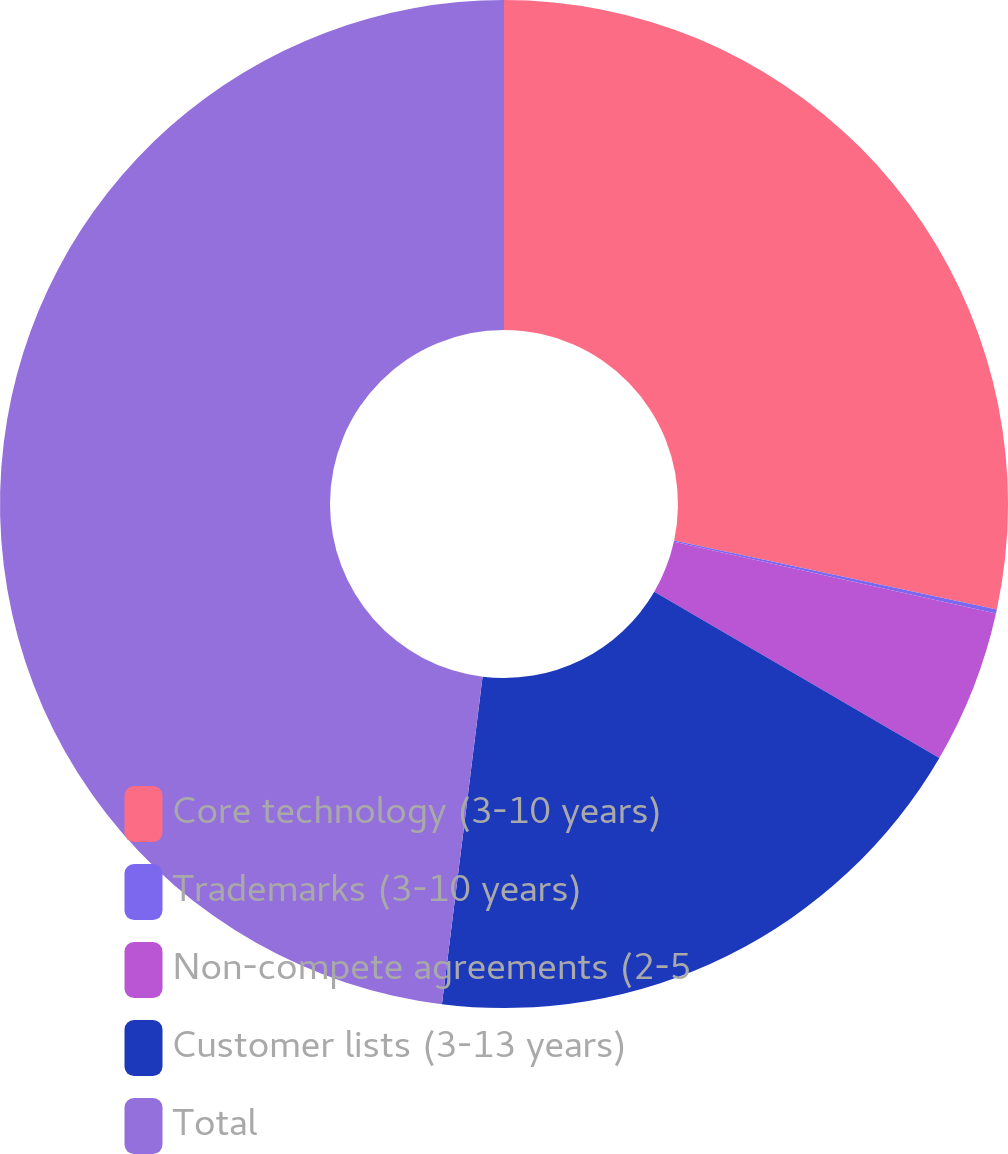Convert chart to OTSL. <chart><loc_0><loc_0><loc_500><loc_500><pie_chart><fcel>Core technology (3-10 years)<fcel>Trademarks (3-10 years)<fcel>Non-compete agreements (2-5<fcel>Customer lists (3-13 years)<fcel>Total<nl><fcel>28.35%<fcel>0.13%<fcel>4.92%<fcel>18.56%<fcel>48.03%<nl></chart> 